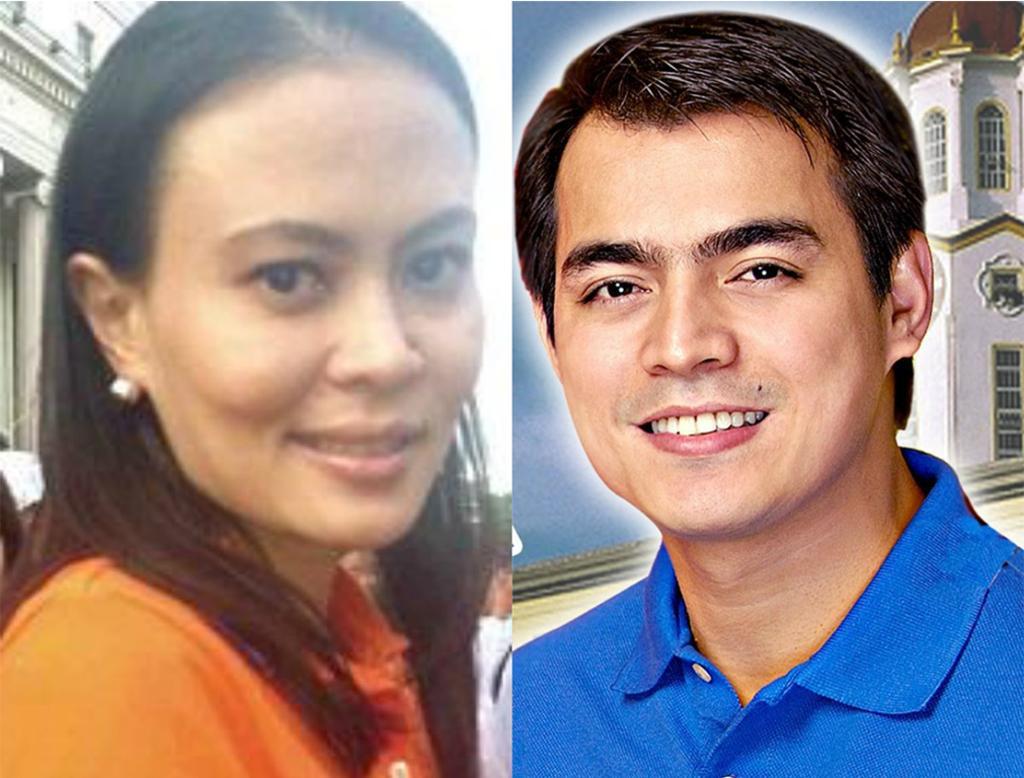Describe this image in one or two sentences. In this image I can see the collage picture and the person at right is wearing blue color shirt and the person at left is wearing an orange color dress. Background I can see few buildings in cream and white color. 